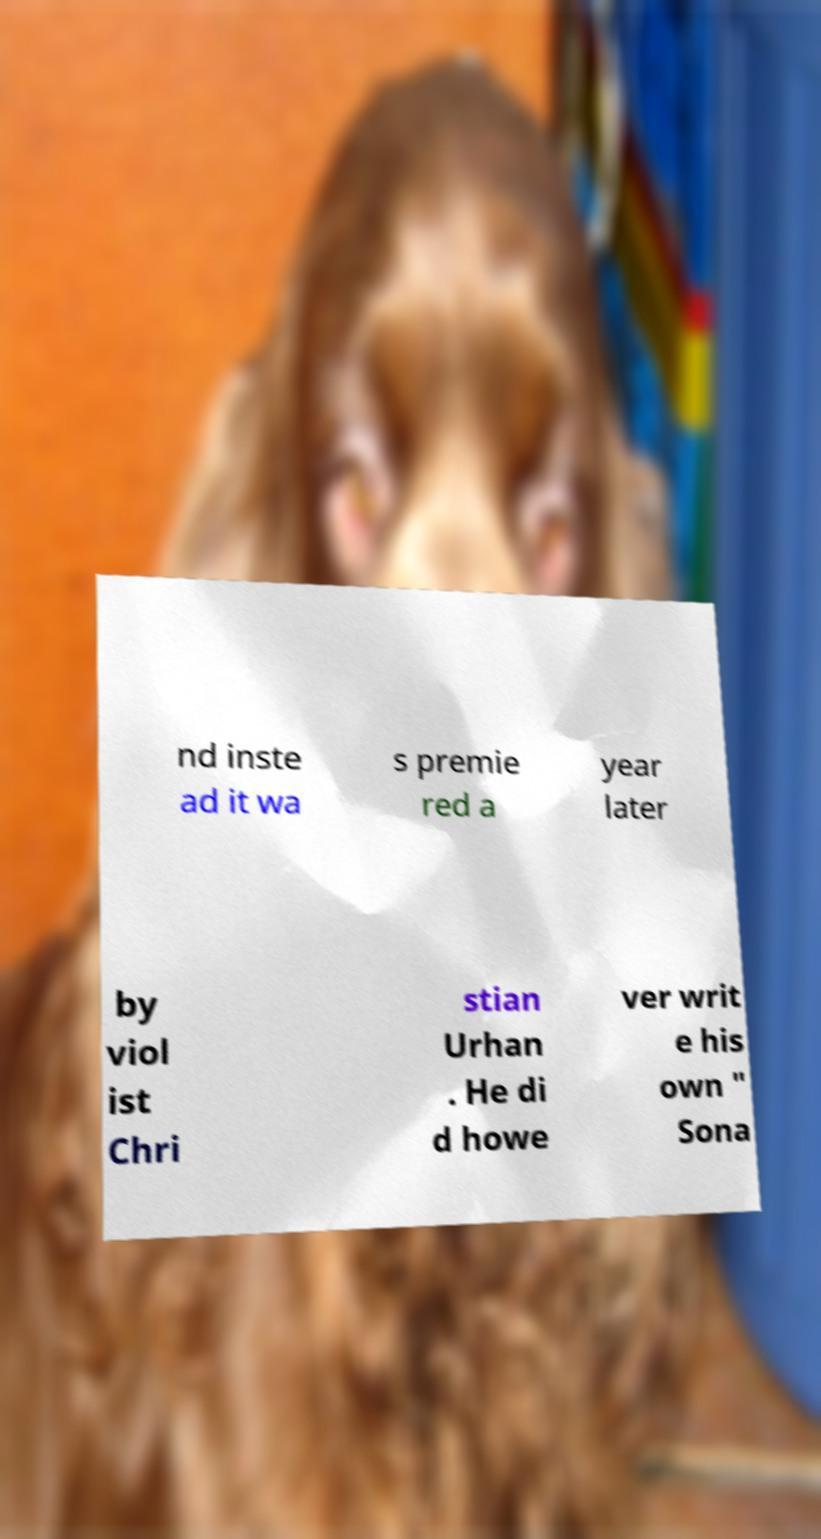Could you extract and type out the text from this image? nd inste ad it wa s premie red a year later by viol ist Chri stian Urhan . He di d howe ver writ e his own " Sona 